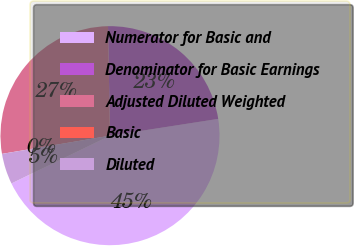<chart> <loc_0><loc_0><loc_500><loc_500><pie_chart><fcel>Numerator for Basic and<fcel>Denominator for Basic Earnings<fcel>Adjusted Diluted Weighted<fcel>Basic<fcel>Diluted<nl><fcel>45.27%<fcel>22.84%<fcel>27.37%<fcel>0.0%<fcel>4.53%<nl></chart> 